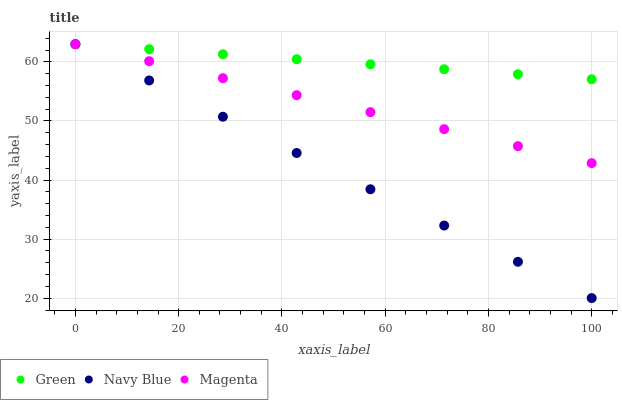Does Navy Blue have the minimum area under the curve?
Answer yes or no. Yes. Does Green have the maximum area under the curve?
Answer yes or no. Yes. Does Magenta have the minimum area under the curve?
Answer yes or no. No. Does Magenta have the maximum area under the curve?
Answer yes or no. No. Is Green the smoothest?
Answer yes or no. Yes. Is Magenta the roughest?
Answer yes or no. Yes. Is Magenta the smoothest?
Answer yes or no. No. Is Green the roughest?
Answer yes or no. No. Does Navy Blue have the lowest value?
Answer yes or no. Yes. Does Magenta have the lowest value?
Answer yes or no. No. Does Green have the highest value?
Answer yes or no. Yes. Does Navy Blue intersect Green?
Answer yes or no. Yes. Is Navy Blue less than Green?
Answer yes or no. No. Is Navy Blue greater than Green?
Answer yes or no. No. 